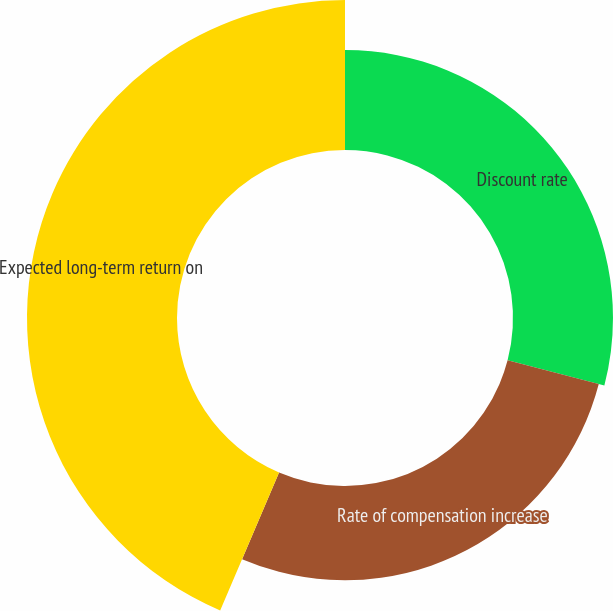Convert chart to OTSL. <chart><loc_0><loc_0><loc_500><loc_500><pie_chart><fcel>Discount rate<fcel>Rate of compensation increase<fcel>Expected long-term return on<nl><fcel>29.05%<fcel>27.37%<fcel>43.58%<nl></chart> 